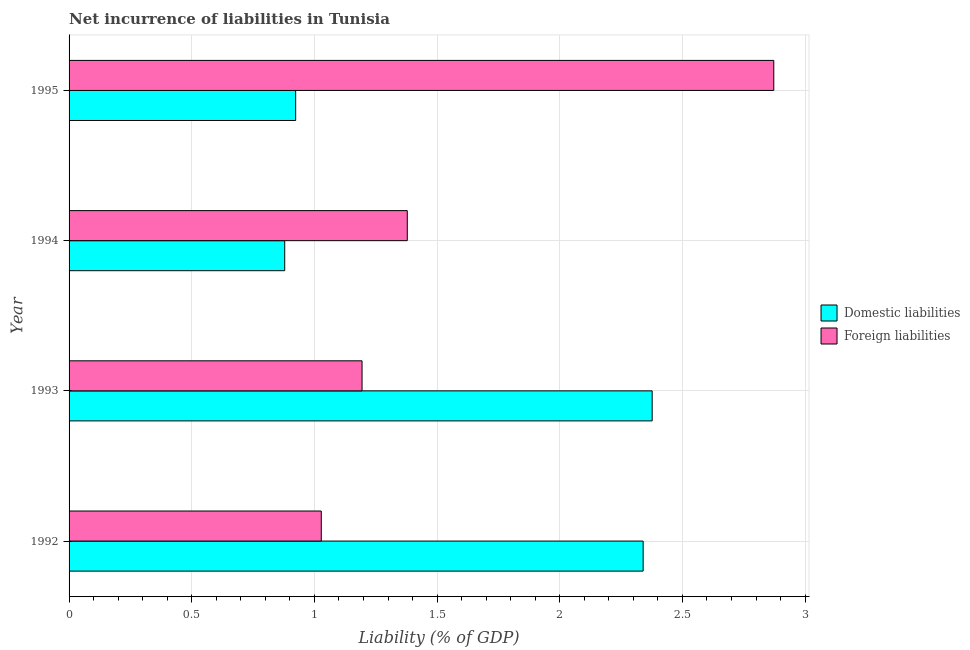Are the number of bars per tick equal to the number of legend labels?
Your answer should be very brief. Yes. How many bars are there on the 2nd tick from the top?
Provide a short and direct response. 2. In how many cases, is the number of bars for a given year not equal to the number of legend labels?
Provide a short and direct response. 0. What is the incurrence of domestic liabilities in 1993?
Provide a short and direct response. 2.38. Across all years, what is the maximum incurrence of domestic liabilities?
Make the answer very short. 2.38. Across all years, what is the minimum incurrence of domestic liabilities?
Provide a short and direct response. 0.88. In which year was the incurrence of domestic liabilities maximum?
Ensure brevity in your answer.  1993. What is the total incurrence of foreign liabilities in the graph?
Your answer should be very brief. 6.47. What is the difference between the incurrence of foreign liabilities in 1992 and that in 1994?
Provide a short and direct response. -0.35. What is the difference between the incurrence of domestic liabilities in 1995 and the incurrence of foreign liabilities in 1994?
Provide a short and direct response. -0.45. What is the average incurrence of foreign liabilities per year?
Your answer should be very brief. 1.62. In the year 1995, what is the difference between the incurrence of domestic liabilities and incurrence of foreign liabilities?
Your answer should be compact. -1.95. In how many years, is the incurrence of domestic liabilities greater than 1.6 %?
Your answer should be very brief. 2. What is the ratio of the incurrence of foreign liabilities in 1994 to that in 1995?
Your answer should be compact. 0.48. Is the incurrence of domestic liabilities in 1993 less than that in 1995?
Offer a very short reply. No. What is the difference between the highest and the second highest incurrence of domestic liabilities?
Give a very brief answer. 0.04. What is the difference between the highest and the lowest incurrence of foreign liabilities?
Provide a short and direct response. 1.84. In how many years, is the incurrence of domestic liabilities greater than the average incurrence of domestic liabilities taken over all years?
Keep it short and to the point. 2. What does the 1st bar from the top in 1992 represents?
Give a very brief answer. Foreign liabilities. What does the 2nd bar from the bottom in 1992 represents?
Provide a short and direct response. Foreign liabilities. How many years are there in the graph?
Give a very brief answer. 4. Are the values on the major ticks of X-axis written in scientific E-notation?
Give a very brief answer. No. Does the graph contain any zero values?
Make the answer very short. No. Does the graph contain grids?
Provide a succinct answer. Yes. Where does the legend appear in the graph?
Offer a terse response. Center right. How are the legend labels stacked?
Offer a very short reply. Vertical. What is the title of the graph?
Keep it short and to the point. Net incurrence of liabilities in Tunisia. What is the label or title of the X-axis?
Make the answer very short. Liability (% of GDP). What is the Liability (% of GDP) of Domestic liabilities in 1992?
Offer a terse response. 2.34. What is the Liability (% of GDP) of Foreign liabilities in 1992?
Ensure brevity in your answer.  1.03. What is the Liability (% of GDP) of Domestic liabilities in 1993?
Ensure brevity in your answer.  2.38. What is the Liability (% of GDP) of Foreign liabilities in 1993?
Keep it short and to the point. 1.19. What is the Liability (% of GDP) in Domestic liabilities in 1994?
Make the answer very short. 0.88. What is the Liability (% of GDP) of Foreign liabilities in 1994?
Ensure brevity in your answer.  1.38. What is the Liability (% of GDP) in Domestic liabilities in 1995?
Provide a short and direct response. 0.92. What is the Liability (% of GDP) in Foreign liabilities in 1995?
Ensure brevity in your answer.  2.87. Across all years, what is the maximum Liability (% of GDP) in Domestic liabilities?
Offer a terse response. 2.38. Across all years, what is the maximum Liability (% of GDP) of Foreign liabilities?
Your answer should be compact. 2.87. Across all years, what is the minimum Liability (% of GDP) in Domestic liabilities?
Provide a succinct answer. 0.88. Across all years, what is the minimum Liability (% of GDP) of Foreign liabilities?
Keep it short and to the point. 1.03. What is the total Liability (% of GDP) of Domestic liabilities in the graph?
Provide a short and direct response. 6.52. What is the total Liability (% of GDP) of Foreign liabilities in the graph?
Make the answer very short. 6.47. What is the difference between the Liability (% of GDP) in Domestic liabilities in 1992 and that in 1993?
Provide a short and direct response. -0.04. What is the difference between the Liability (% of GDP) of Foreign liabilities in 1992 and that in 1993?
Your response must be concise. -0.17. What is the difference between the Liability (% of GDP) in Domestic liabilities in 1992 and that in 1994?
Offer a very short reply. 1.46. What is the difference between the Liability (% of GDP) in Foreign liabilities in 1992 and that in 1994?
Keep it short and to the point. -0.35. What is the difference between the Liability (% of GDP) of Domestic liabilities in 1992 and that in 1995?
Your answer should be compact. 1.42. What is the difference between the Liability (% of GDP) of Foreign liabilities in 1992 and that in 1995?
Offer a terse response. -1.84. What is the difference between the Liability (% of GDP) in Domestic liabilities in 1993 and that in 1994?
Offer a very short reply. 1.5. What is the difference between the Liability (% of GDP) in Foreign liabilities in 1993 and that in 1994?
Offer a very short reply. -0.18. What is the difference between the Liability (% of GDP) in Domestic liabilities in 1993 and that in 1995?
Make the answer very short. 1.45. What is the difference between the Liability (% of GDP) in Foreign liabilities in 1993 and that in 1995?
Provide a short and direct response. -1.68. What is the difference between the Liability (% of GDP) of Domestic liabilities in 1994 and that in 1995?
Offer a very short reply. -0.04. What is the difference between the Liability (% of GDP) of Foreign liabilities in 1994 and that in 1995?
Your answer should be very brief. -1.49. What is the difference between the Liability (% of GDP) in Domestic liabilities in 1992 and the Liability (% of GDP) in Foreign liabilities in 1993?
Ensure brevity in your answer.  1.15. What is the difference between the Liability (% of GDP) in Domestic liabilities in 1992 and the Liability (% of GDP) in Foreign liabilities in 1994?
Ensure brevity in your answer.  0.96. What is the difference between the Liability (% of GDP) of Domestic liabilities in 1992 and the Liability (% of GDP) of Foreign liabilities in 1995?
Keep it short and to the point. -0.53. What is the difference between the Liability (% of GDP) of Domestic liabilities in 1993 and the Liability (% of GDP) of Foreign liabilities in 1995?
Ensure brevity in your answer.  -0.5. What is the difference between the Liability (% of GDP) of Domestic liabilities in 1994 and the Liability (% of GDP) of Foreign liabilities in 1995?
Give a very brief answer. -1.99. What is the average Liability (% of GDP) of Domestic liabilities per year?
Offer a very short reply. 1.63. What is the average Liability (% of GDP) of Foreign liabilities per year?
Provide a short and direct response. 1.62. In the year 1992, what is the difference between the Liability (% of GDP) in Domestic liabilities and Liability (% of GDP) in Foreign liabilities?
Offer a terse response. 1.31. In the year 1993, what is the difference between the Liability (% of GDP) of Domestic liabilities and Liability (% of GDP) of Foreign liabilities?
Provide a succinct answer. 1.18. In the year 1994, what is the difference between the Liability (% of GDP) of Domestic liabilities and Liability (% of GDP) of Foreign liabilities?
Make the answer very short. -0.5. In the year 1995, what is the difference between the Liability (% of GDP) of Domestic liabilities and Liability (% of GDP) of Foreign liabilities?
Your answer should be very brief. -1.95. What is the ratio of the Liability (% of GDP) in Domestic liabilities in 1992 to that in 1993?
Give a very brief answer. 0.98. What is the ratio of the Liability (% of GDP) of Foreign liabilities in 1992 to that in 1993?
Give a very brief answer. 0.86. What is the ratio of the Liability (% of GDP) of Domestic liabilities in 1992 to that in 1994?
Provide a succinct answer. 2.66. What is the ratio of the Liability (% of GDP) of Foreign liabilities in 1992 to that in 1994?
Provide a succinct answer. 0.75. What is the ratio of the Liability (% of GDP) in Domestic liabilities in 1992 to that in 1995?
Offer a very short reply. 2.53. What is the ratio of the Liability (% of GDP) in Foreign liabilities in 1992 to that in 1995?
Your answer should be compact. 0.36. What is the ratio of the Liability (% of GDP) in Domestic liabilities in 1993 to that in 1994?
Your answer should be very brief. 2.7. What is the ratio of the Liability (% of GDP) of Foreign liabilities in 1993 to that in 1994?
Provide a succinct answer. 0.87. What is the ratio of the Liability (% of GDP) in Domestic liabilities in 1993 to that in 1995?
Offer a terse response. 2.57. What is the ratio of the Liability (% of GDP) of Foreign liabilities in 1993 to that in 1995?
Provide a short and direct response. 0.42. What is the ratio of the Liability (% of GDP) of Domestic liabilities in 1994 to that in 1995?
Offer a very short reply. 0.95. What is the ratio of the Liability (% of GDP) of Foreign liabilities in 1994 to that in 1995?
Your answer should be very brief. 0.48. What is the difference between the highest and the second highest Liability (% of GDP) in Domestic liabilities?
Ensure brevity in your answer.  0.04. What is the difference between the highest and the second highest Liability (% of GDP) in Foreign liabilities?
Offer a terse response. 1.49. What is the difference between the highest and the lowest Liability (% of GDP) of Domestic liabilities?
Offer a terse response. 1.5. What is the difference between the highest and the lowest Liability (% of GDP) in Foreign liabilities?
Provide a short and direct response. 1.84. 